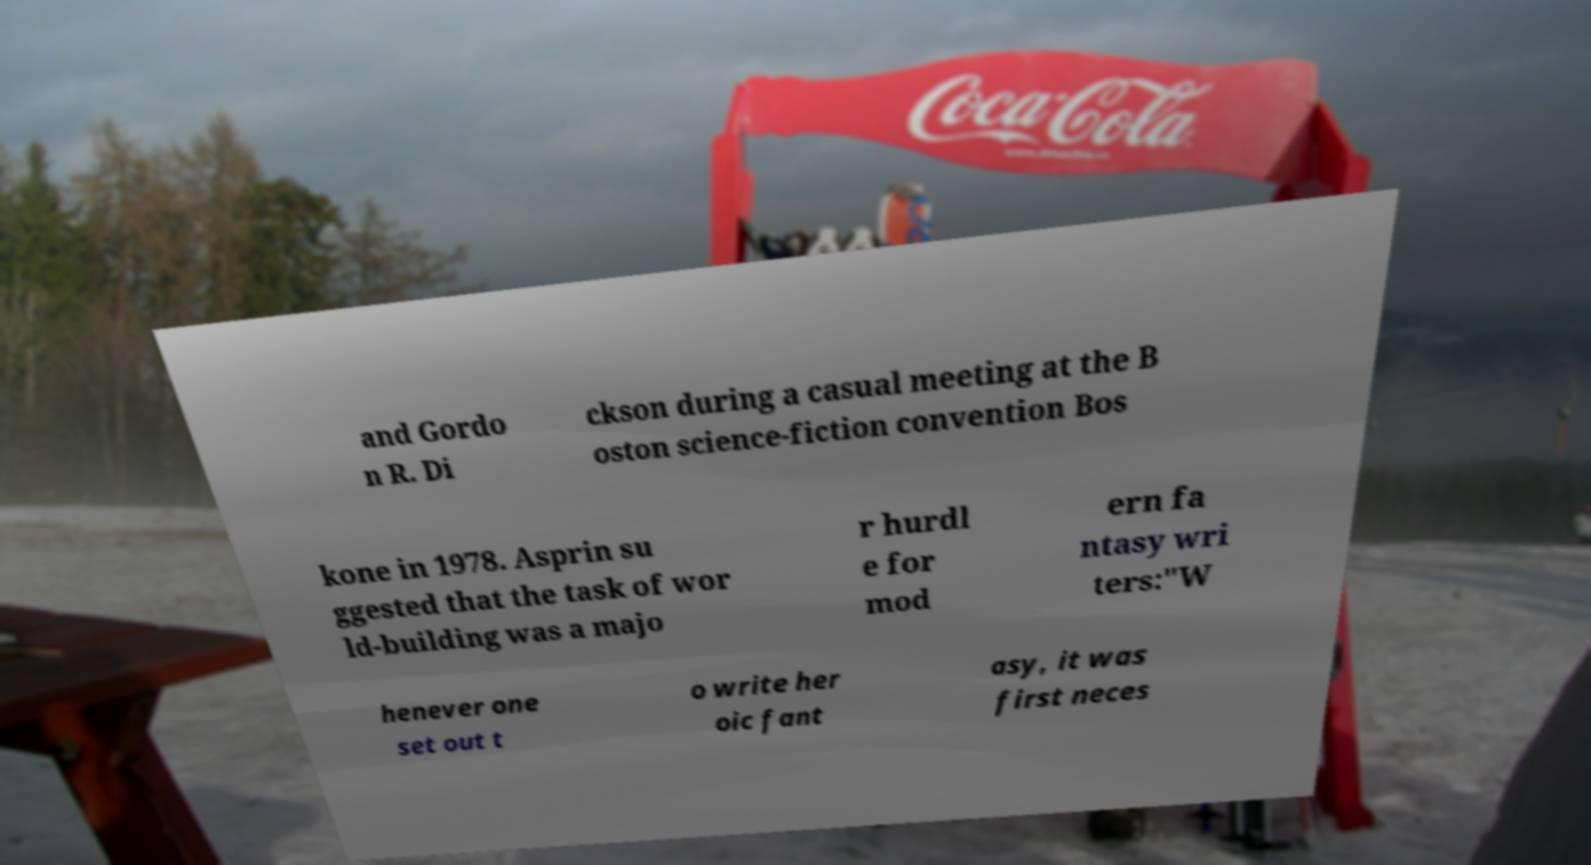Please read and relay the text visible in this image. What does it say? and Gordo n R. Di ckson during a casual meeting at the B oston science-fiction convention Bos kone in 1978. Asprin su ggested that the task of wor ld-building was a majo r hurdl e for mod ern fa ntasy wri ters:"W henever one set out t o write her oic fant asy, it was first neces 